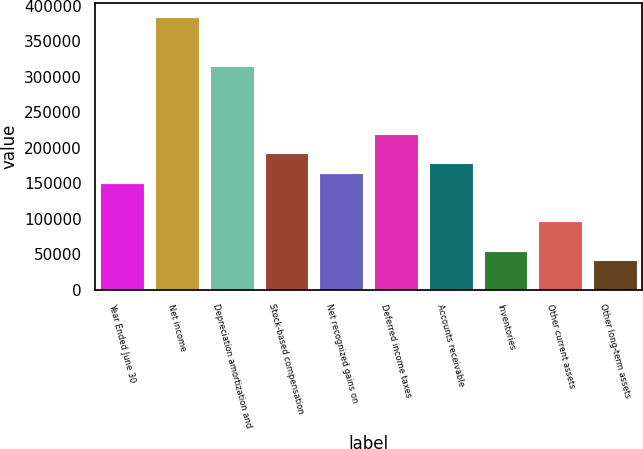Convert chart to OTSL. <chart><loc_0><loc_0><loc_500><loc_500><bar_chart><fcel>Year Ended June 30<fcel>Net income<fcel>Depreciation amortization and<fcel>Stock-based compensation<fcel>Net recognized gains on<fcel>Deferred income taxes<fcel>Accounts receivable<fcel>Inventories<fcel>Other current assets<fcel>Other long-term assets<nl><fcel>151116<fcel>384628<fcel>315948<fcel>192324<fcel>164852<fcel>219796<fcel>178588<fcel>54964<fcel>96172<fcel>41228<nl></chart> 